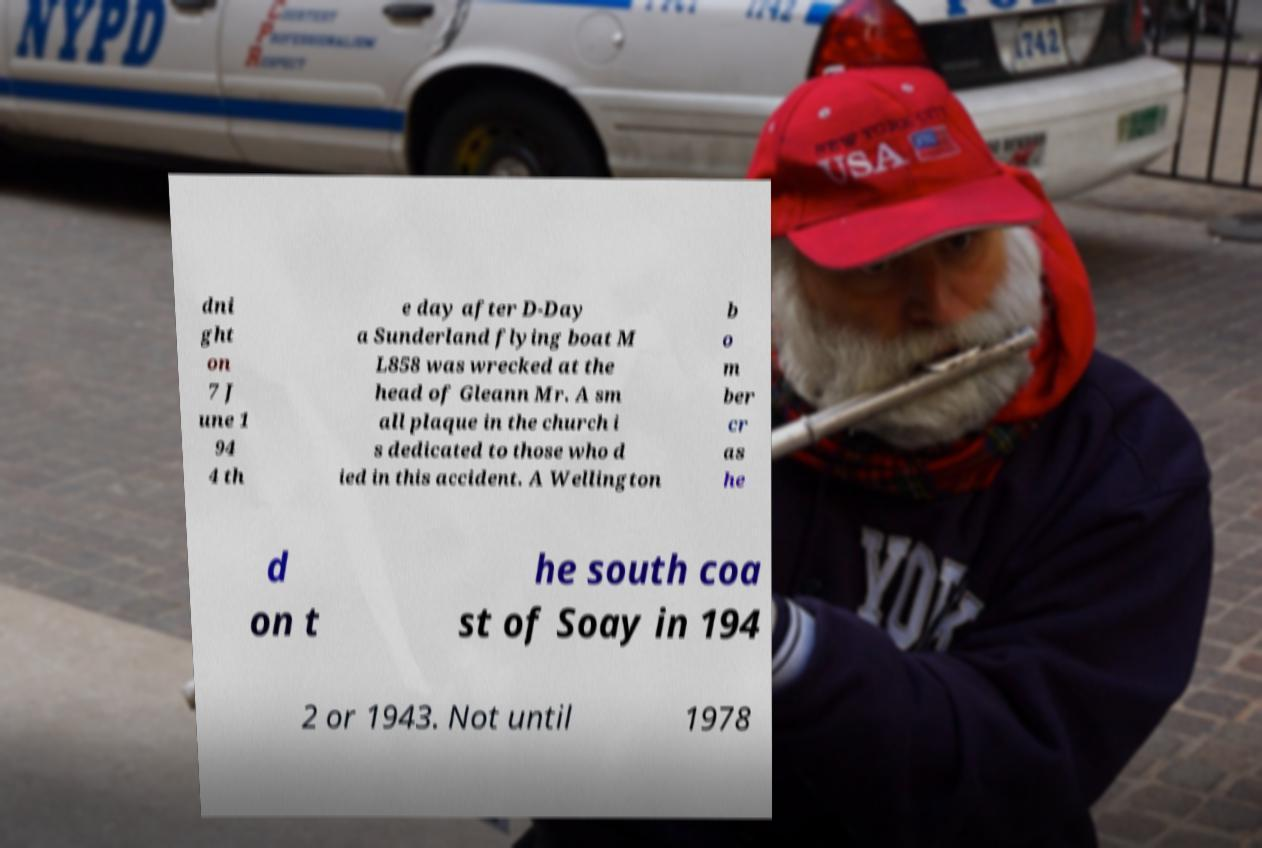Could you assist in decoding the text presented in this image and type it out clearly? dni ght on 7 J une 1 94 4 th e day after D-Day a Sunderland flying boat M L858 was wrecked at the head of Gleann Mr. A sm all plaque in the church i s dedicated to those who d ied in this accident. A Wellington b o m ber cr as he d on t he south coa st of Soay in 194 2 or 1943. Not until 1978 